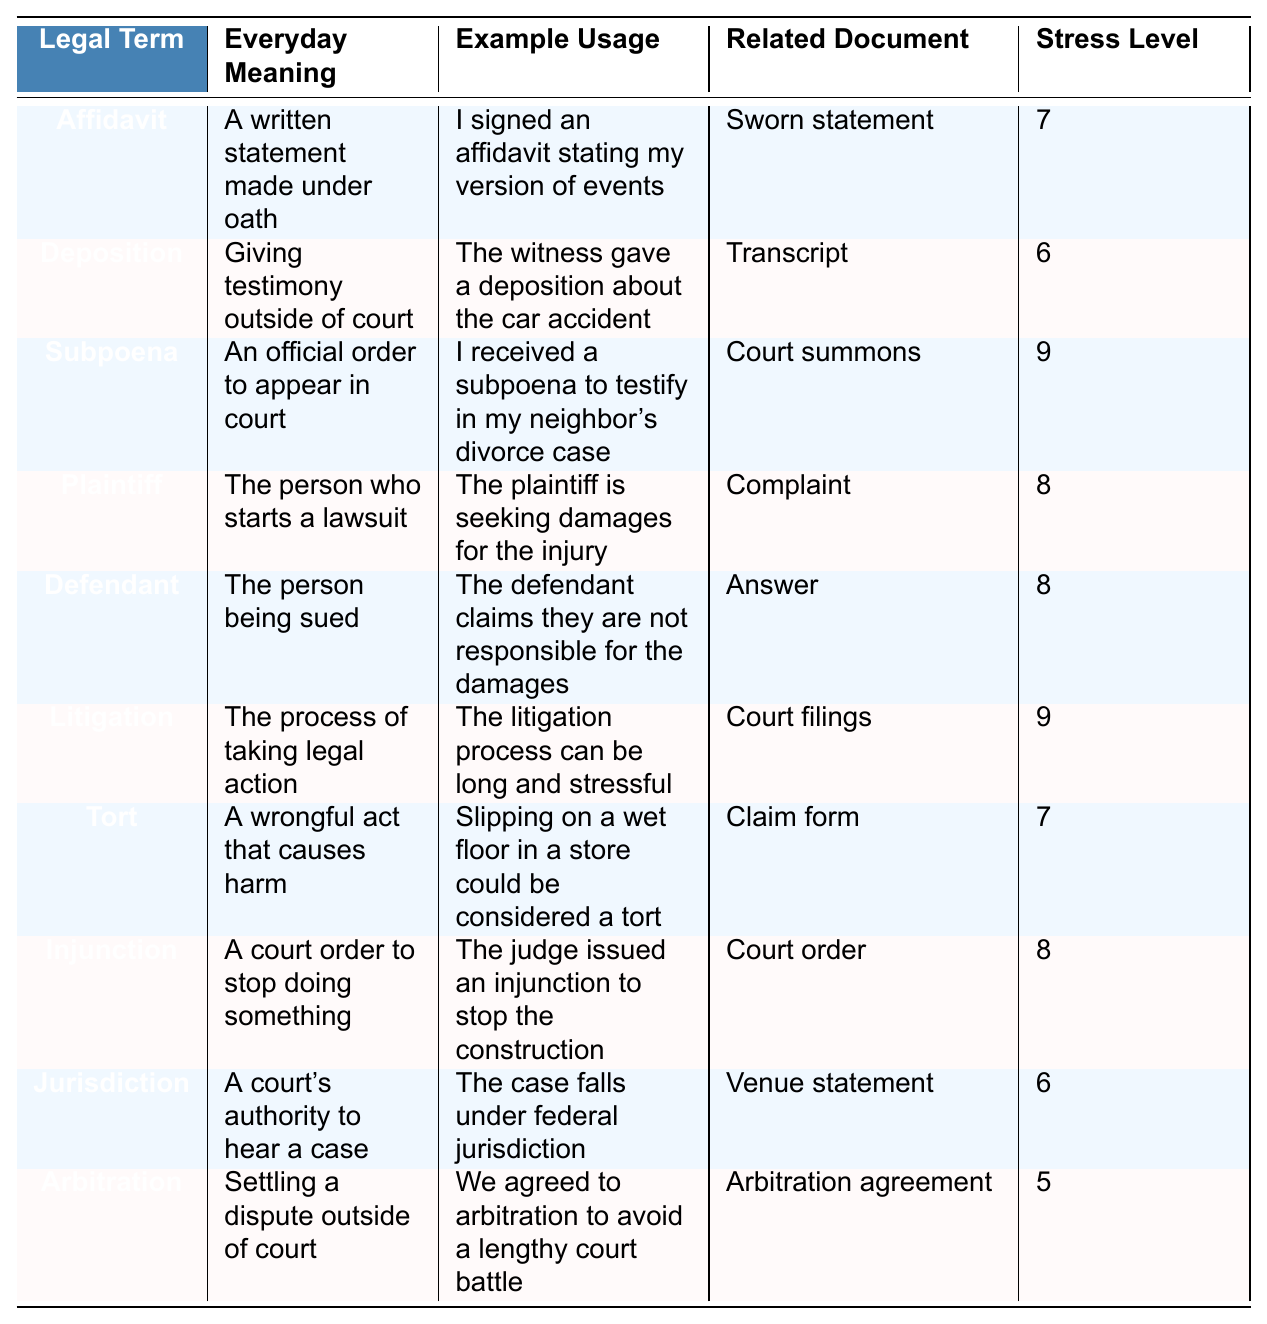What does "Affidavit" mean in everyday language? The everyday meaning of "Affidavit" is described in the table as "A written statement made under oath."
Answer: A written statement made under oath Who is the "Plaintiff" in a lawsuit? The table defines "Plaintiff" as "The person who starts a lawsuit."
Answer: The person who starts a lawsuit What is an example of a "Subpoena"? The table gives the example usage: "I received a subpoena to testify in my neighbor's divorce case."
Answer: I received a subpoena to testify in my neighbor's divorce case Which term has the highest stress level according to the table? The stress levels listed show that "Subpoena," "Litigation," and "Deposition" have the highest values, with "Subpoena" at 9.
Answer: Subpoena Does the table indicate that "Arbitration" has a high stress level? The stress level for "Arbitration" is stated as 5, which is relatively low compared to other terms.
Answer: No What is the everyday meaning of "Tort"? According to the table, "Tort" means "A wrongful act that causes harm."
Answer: A wrongful act that causes harm What is the average stress level of the legal terms listed? The stress levels are 7, 6, 9, 8, 8, 9, 7, 8, 6, and 5. Summing these gives 66. Dividing by 10 (the number of terms) gives an average of 6.6.
Answer: 6.6 How many legal terms have a stress level of 8 or higher? The stress levels for the terms that are 8 or higher are "Plaintiff," "Defendant," "Litigation," "Injunction," and "Subpoena." This makes a total of 5 terms.
Answer: 5 What does "Injunction" refer to in simple terms? The table states that "Injunction" means "A court order to stop doing something."
Answer: A court order to stop doing something If a person receives a "Deposition," what might it involve? It involves giving testimony outside of court, as explained in the everyday meaning for "Deposition" in the table.
Answer: Giving testimony outside of court 